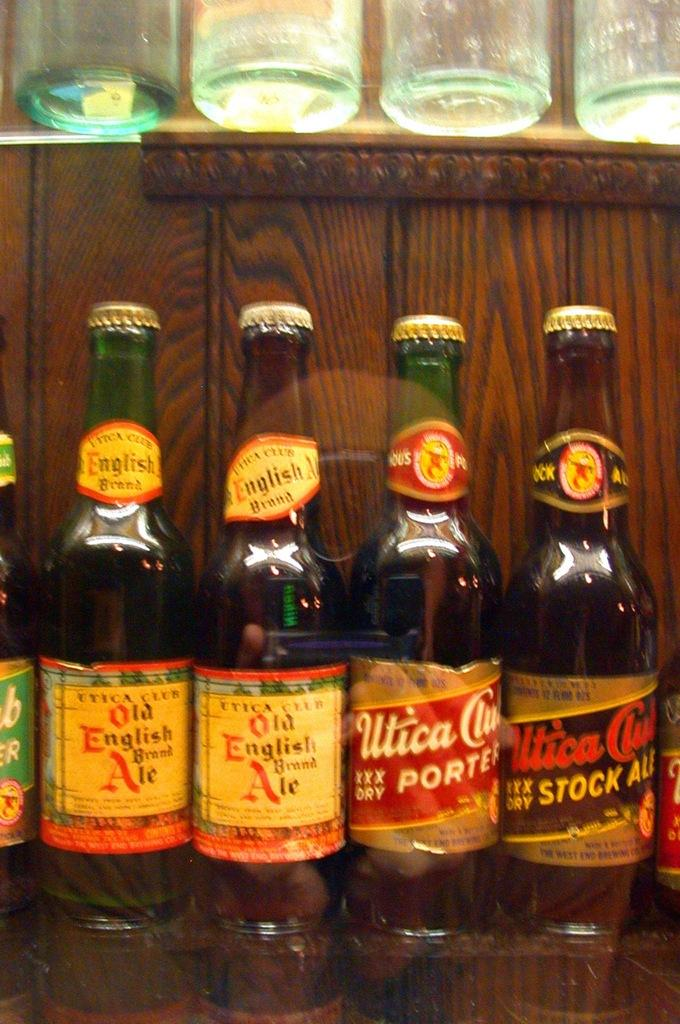<image>
Share a concise interpretation of the image provided. Old English Ale bottles are on display next to the Utica Club bottles. 